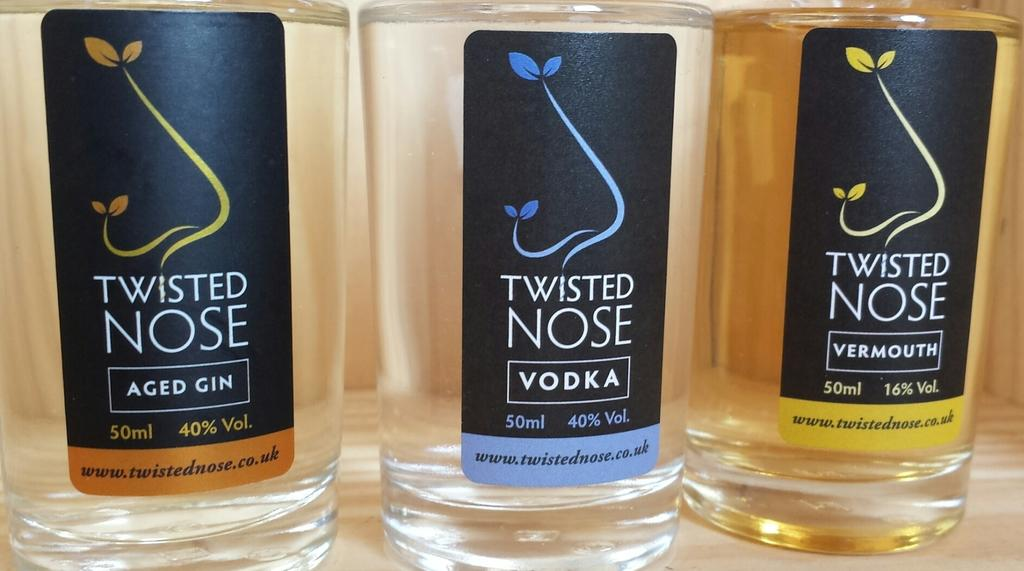<image>
Write a terse but informative summary of the picture. Three bottles of Twisted Nose alcohol are shown for your viewing pleasure. 